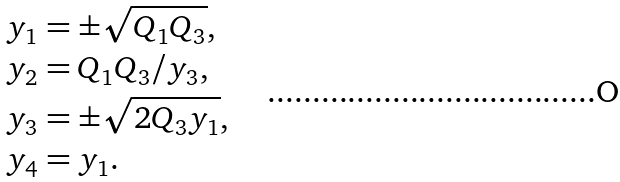Convert formula to latex. <formula><loc_0><loc_0><loc_500><loc_500>y _ { 1 } & = \pm \sqrt { Q _ { 1 } Q _ { 3 } } , \\ y _ { 2 } & = Q _ { 1 } Q _ { 3 } / y _ { 3 } , \\ y _ { 3 } & = \pm \sqrt { 2 Q _ { 3 } y _ { 1 } } , \\ y _ { 4 } & = y _ { 1 } .</formula> 